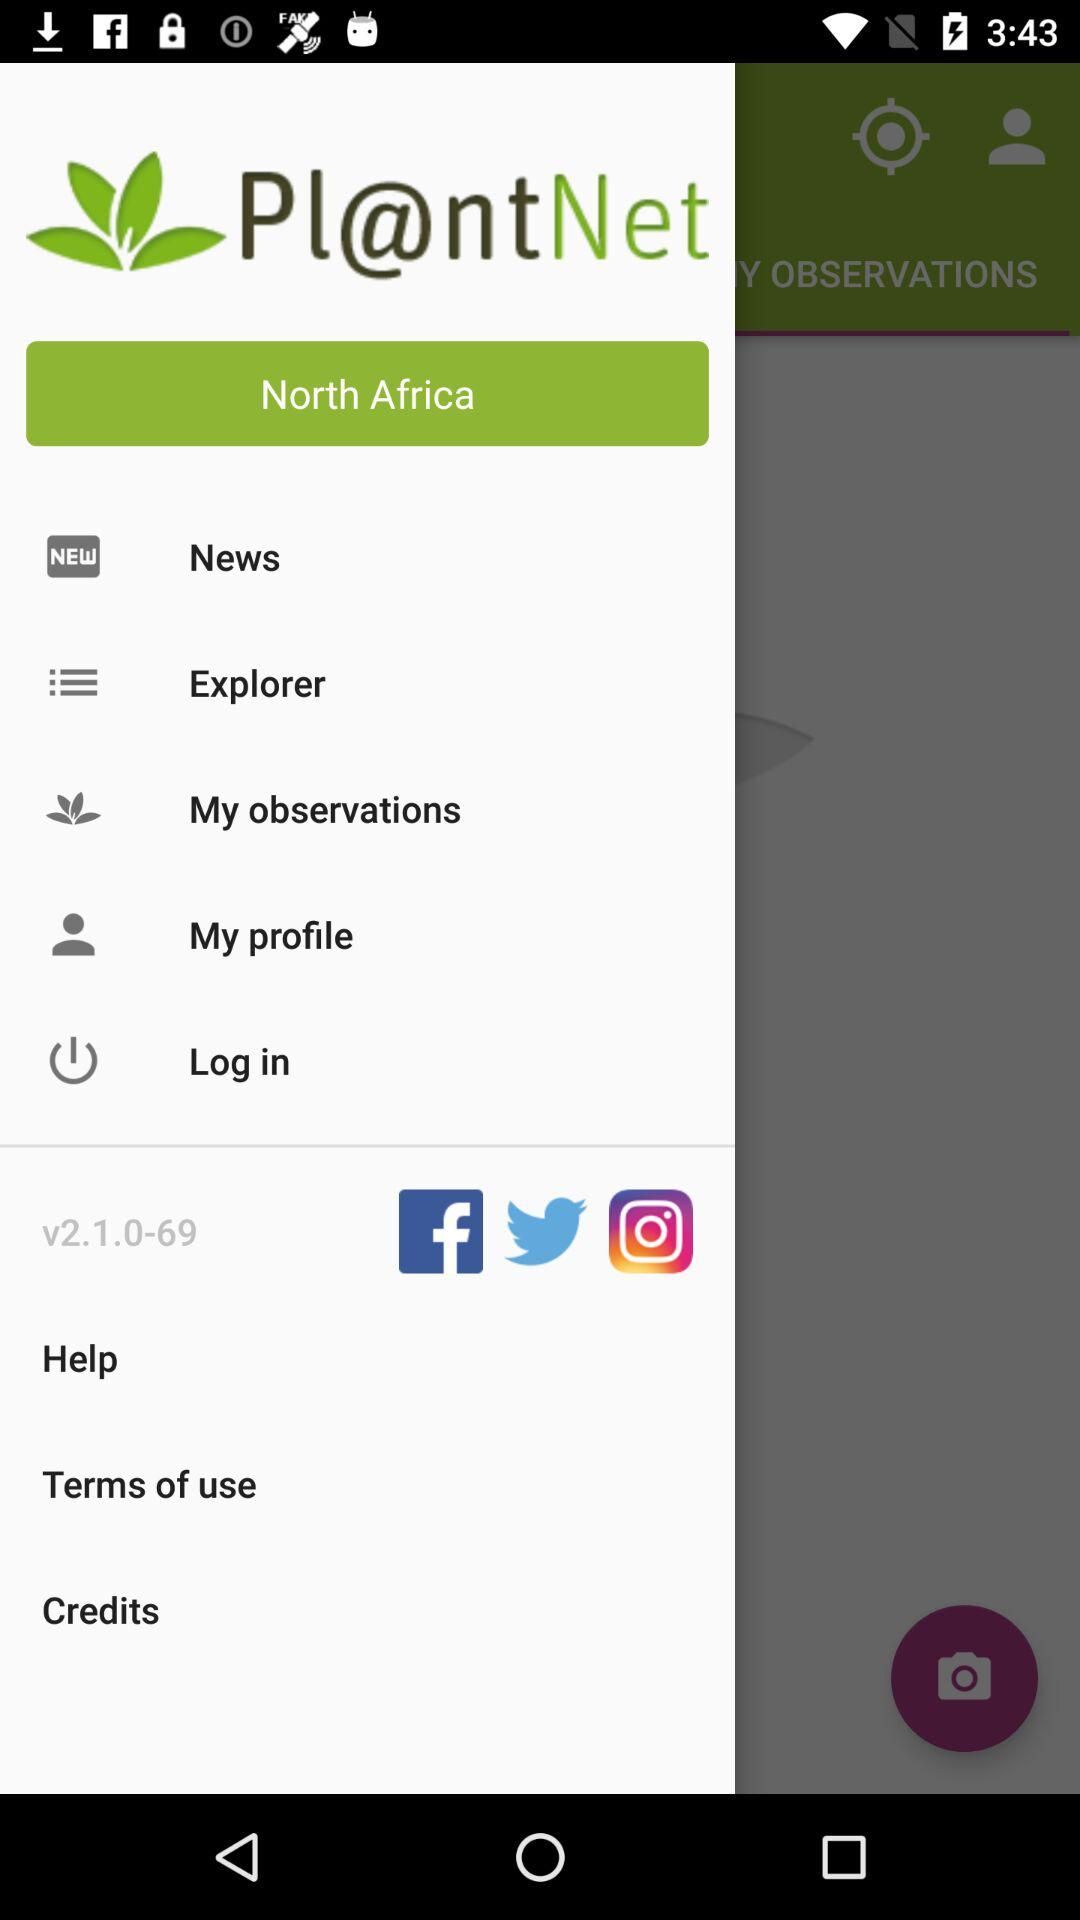What is the application name? The application name is "PlantNet". 